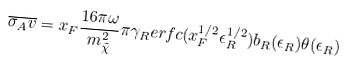<formula> <loc_0><loc_0><loc_500><loc_500>\overline { \sigma _ { A } v } = x _ { F } \frac { 1 6 \pi \omega } { m ^ { 2 } _ { \tilde { \chi } } } \pi \gamma _ { R } e r f c ( x _ { F } ^ { 1 / 2 } \epsilon _ { R } ^ { 1 / 2 } ) b _ { R } ( \epsilon _ { R } ) \theta ( \epsilon _ { R } )</formula> 